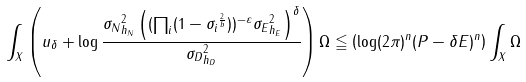Convert formula to latex. <formula><loc_0><loc_0><loc_500><loc_500>\int _ { X } \left ( u _ { \delta } + \log \frac { \| \sigma _ { N } \| _ { h _ { N } } ^ { 2 } \left ( ( \prod _ { i } ( 1 - \| \sigma _ { i } \| ^ { \frac { 2 } { b } } ) ) ^ { - \varepsilon } \| \sigma _ { E } \| _ { h _ { E } } ^ { 2 } \right ) ^ { \delta } } { \| \sigma _ { D } \| ^ { 2 } _ { h _ { D } } } \right ) \Omega \leqq \left ( \log ( 2 \pi ) ^ { n } ( P - \delta E ) ^ { n } \right ) \int _ { X } \Omega</formula> 